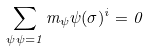Convert formula to latex. <formula><loc_0><loc_0><loc_500><loc_500>\sum _ { \psi \psi = 1 } m _ { \psi } \psi ( \sigma ) ^ { i } = 0</formula> 